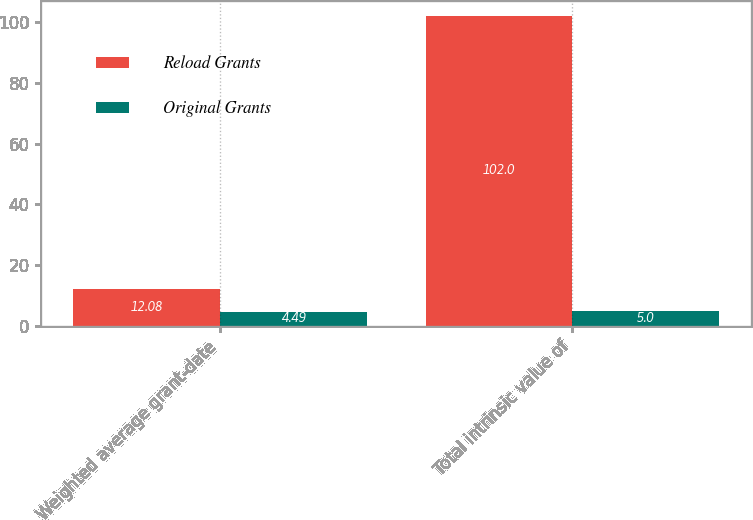Convert chart to OTSL. <chart><loc_0><loc_0><loc_500><loc_500><stacked_bar_chart><ecel><fcel>Weighted average grant-date<fcel>Total intrinsic value of<nl><fcel>Reload Grants<fcel>12.08<fcel>102<nl><fcel>Original Grants<fcel>4.49<fcel>5<nl></chart> 